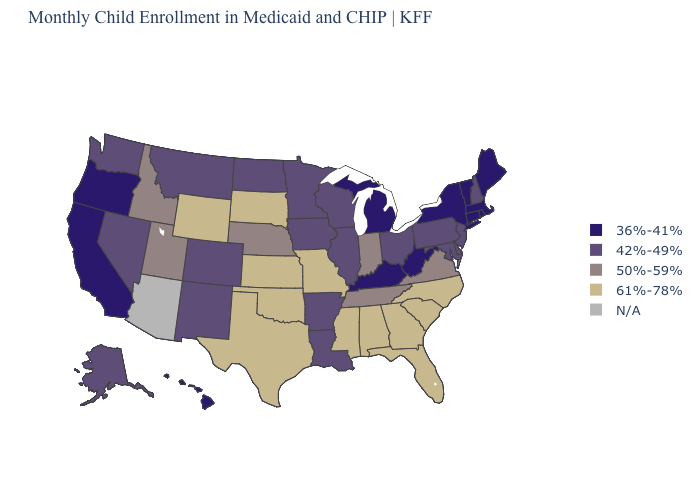What is the value of Montana?
Short answer required. 42%-49%. What is the lowest value in the USA?
Answer briefly. 36%-41%. Name the states that have a value in the range 61%-78%?
Concise answer only. Alabama, Florida, Georgia, Kansas, Mississippi, Missouri, North Carolina, Oklahoma, South Carolina, South Dakota, Texas, Wyoming. Which states hav the highest value in the MidWest?
Keep it brief. Kansas, Missouri, South Dakota. Among the states that border Georgia , which have the lowest value?
Write a very short answer. Tennessee. Does the first symbol in the legend represent the smallest category?
Answer briefly. Yes. What is the value of Alaska?
Write a very short answer. 42%-49%. Which states have the highest value in the USA?
Quick response, please. Alabama, Florida, Georgia, Kansas, Mississippi, Missouri, North Carolina, Oklahoma, South Carolina, South Dakota, Texas, Wyoming. Among the states that border Connecticut , which have the highest value?
Concise answer only. Massachusetts, New York, Rhode Island. Does the map have missing data?
Quick response, please. Yes. What is the value of Wisconsin?
Keep it brief. 42%-49%. 